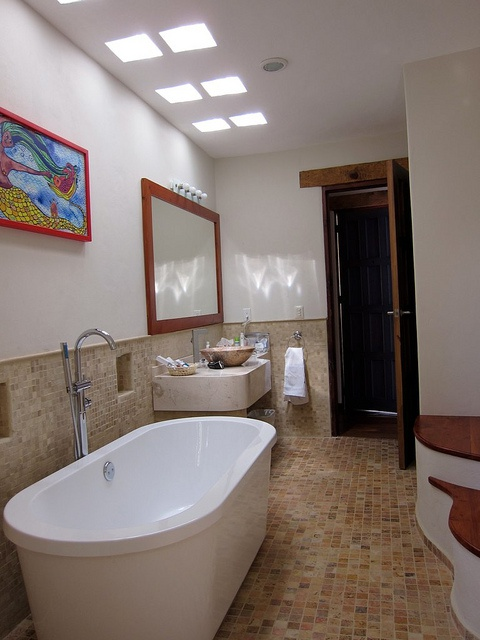Describe the objects in this image and their specific colors. I can see a sink in lightgray, darkgray, and gray tones in this image. 